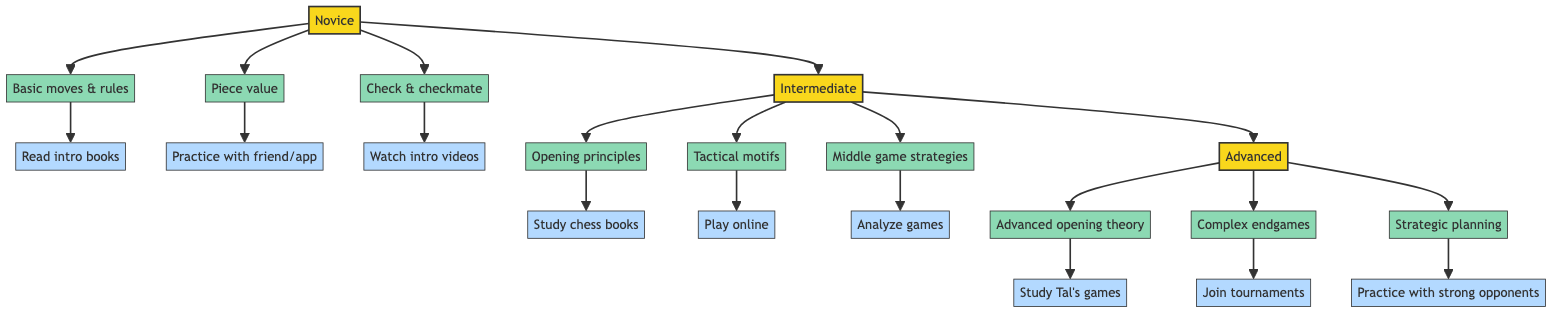What focus area is included in the Novice level? The Novice level contains several focus areas; one of them is "Learning the basic moves and rules," which is listed directly under Novice in the diagram.
Answer: Learning the basic moves and rules What activities are suggested for Intermediate players? The Intermediate level has a few activities suggested; one of them is "Playing regularly in online chess platforms (e.g., Chess.com, Lichess)," which can be found in the activities linked to the Intermediate focus areas.
Answer: Playing regularly in online chess platforms How many levels are in the clinical pathway? The diagram depicts three distinct levels: Novice, Intermediate, and Advanced, so by counting these levels, we identify the total amount present.
Answer: Three What is a focus area for Advanced players? Advanced players focus on "Advanced opening theory," which is one of the elements listed under the Advanced category in the diagram.
Answer: Advanced opening theory Which activity is linked to the focus area of complex endgames? The activity that corresponds to the focus area of complex endgames is "Join tournaments," which is directly linked to the focus of Advanced players concerning endgames.
Answer: Join tournaments What is the relationship between Novice and Intermediate levels? The relationship shows a direct progression where Novice leads to Intermediate, indicating that students typically progress from Novice to Intermediate in the clinical pathway.
Answer: Novice leads to Intermediate How many focus areas are identified under the Intermediate level? The Intermediate level has three focus areas: basic opening principles, recognizing tactical motifs, and developing middle game strategies; by counting these listed focus areas, we arrive at the number.
Answer: Three What type of activities do Advanced players engage in? Advanced players engage in activities like studying works of great players, participating in local tournaments, and practicing with stronger opponents, showcasing the depth of practice at this level.
Answer: Study works of great players What is the primary goal of someone at the Novice level? The primary goal at the Novice level revolves around learning fundamental concepts like the basic moves and rules, aiming to establish a foundation in chess.
Answer: Learning the basic moves and rules 